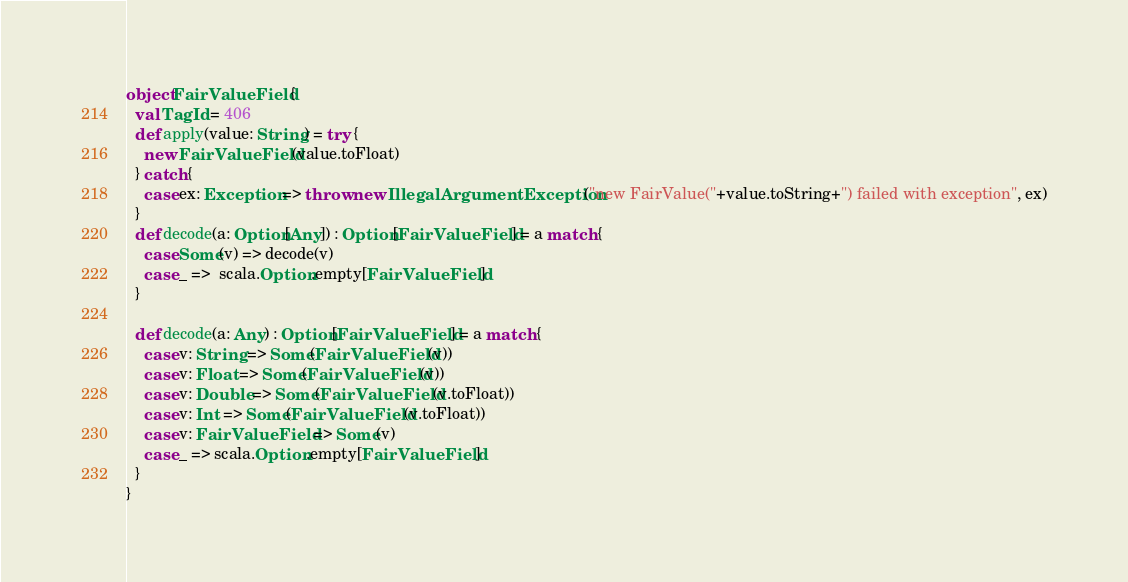Convert code to text. <code><loc_0><loc_0><loc_500><loc_500><_Scala_>object FairValueField {
  val TagId = 406  
  def apply(value: String) = try {
    new FairValueField(value.toFloat)
  } catch {
    case ex: Exception => throw new IllegalArgumentException("new FairValue("+value.toString+") failed with exception", ex)
  } 
  def decode(a: Option[Any]) : Option[FairValueField] = a match {
    case Some(v) => decode(v)
    case _ =>  scala.Option.empty[FairValueField]
  }

  def decode(a: Any) : Option[FairValueField] = a match {
    case v: String => Some(FairValueField(v))
    case v: Float => Some(FairValueField(v))
    case v: Double => Some(FairValueField(v.toFloat))
    case v: Int => Some(FairValueField(v.toFloat))
    case v: FairValueField => Some(v)
    case _ => scala.Option.empty[FairValueField]
  } 
}
</code> 